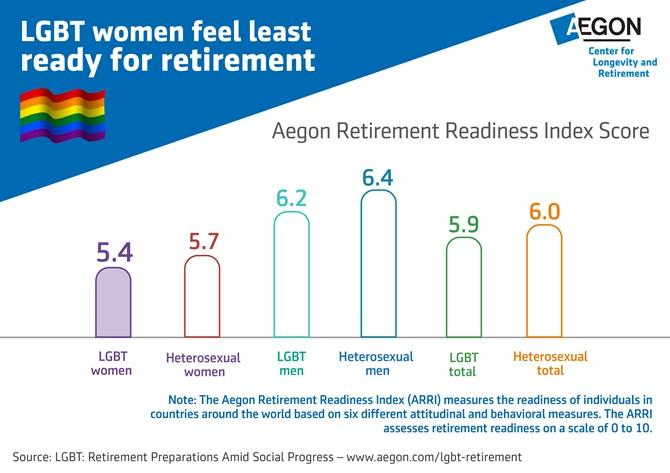Specify some key components in this picture. The group with the lowest score on the Aegon retirement readiness index among heterosexuals is heterosexual women. It is clear that heterosexual men are most prepared for retirement. 